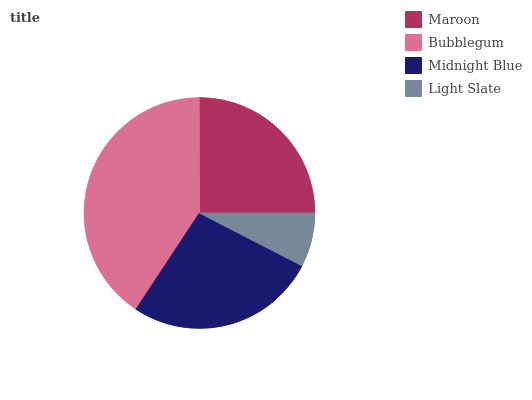Is Light Slate the minimum?
Answer yes or no. Yes. Is Bubblegum the maximum?
Answer yes or no. Yes. Is Midnight Blue the minimum?
Answer yes or no. No. Is Midnight Blue the maximum?
Answer yes or no. No. Is Bubblegum greater than Midnight Blue?
Answer yes or no. Yes. Is Midnight Blue less than Bubblegum?
Answer yes or no. Yes. Is Midnight Blue greater than Bubblegum?
Answer yes or no. No. Is Bubblegum less than Midnight Blue?
Answer yes or no. No. Is Midnight Blue the high median?
Answer yes or no. Yes. Is Maroon the low median?
Answer yes or no. Yes. Is Light Slate the high median?
Answer yes or no. No. Is Light Slate the low median?
Answer yes or no. No. 